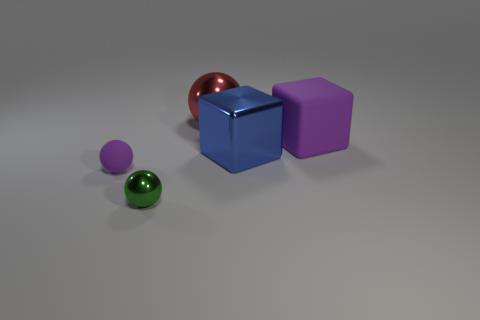If we were to add another object into this scene, what do you think would complement it? Considering the simplicity and color balance of the scene, adding another geometric shape like a cylinder or a pyramid in a complementary color such as a soft orange or yellow could enhance the visual interest without overwhelming the existing harmony. 